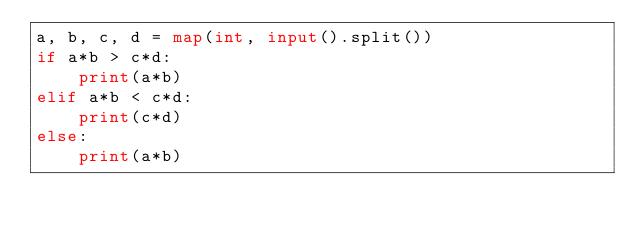Convert code to text. <code><loc_0><loc_0><loc_500><loc_500><_Python_>a, b, c, d = map(int, input().split())
if a*b > c*d:
    print(a*b)
elif a*b < c*d:
    print(c*d)
else:
    print(a*b)  
</code> 